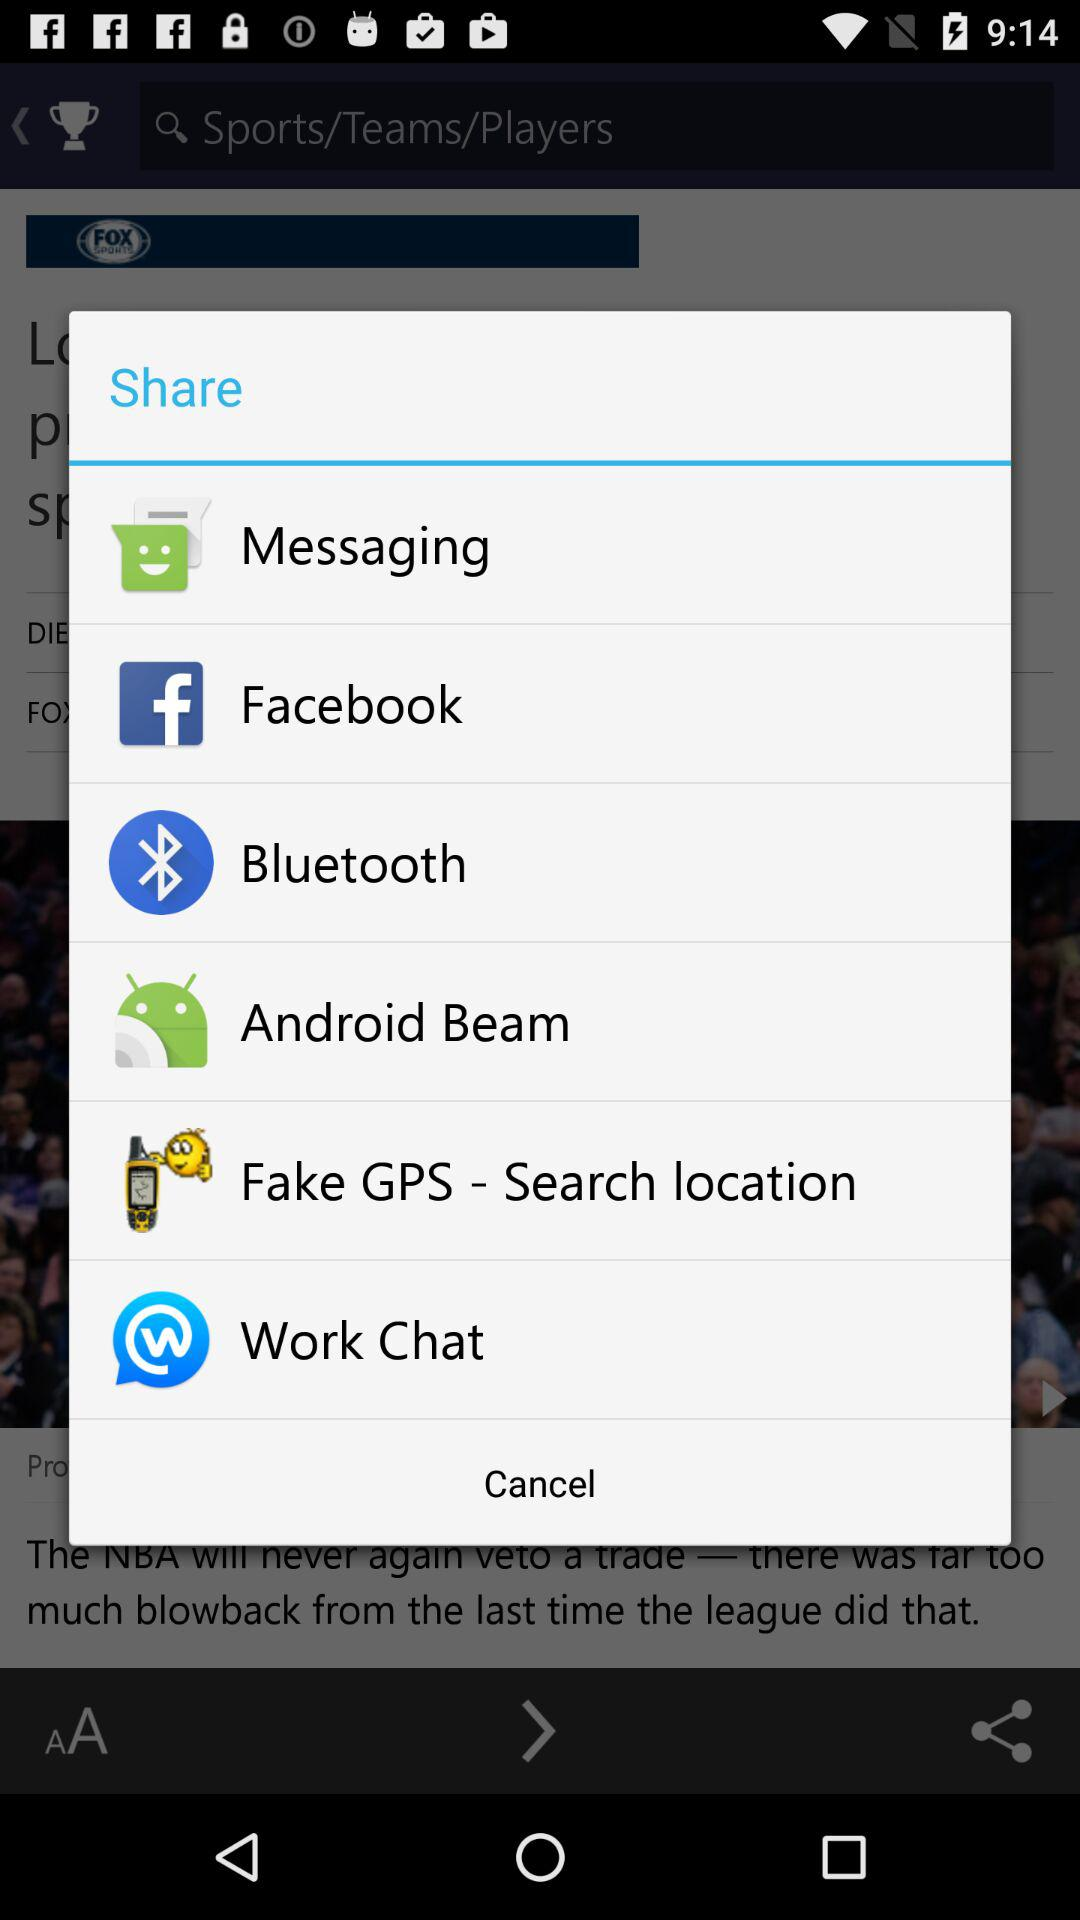Which application can I choose to share? The applications that you can choose to share are "Messaging", "Facebook", "Bluetooth", "Android Beam", "Fake GPS - Search location" and "Work Chat". 